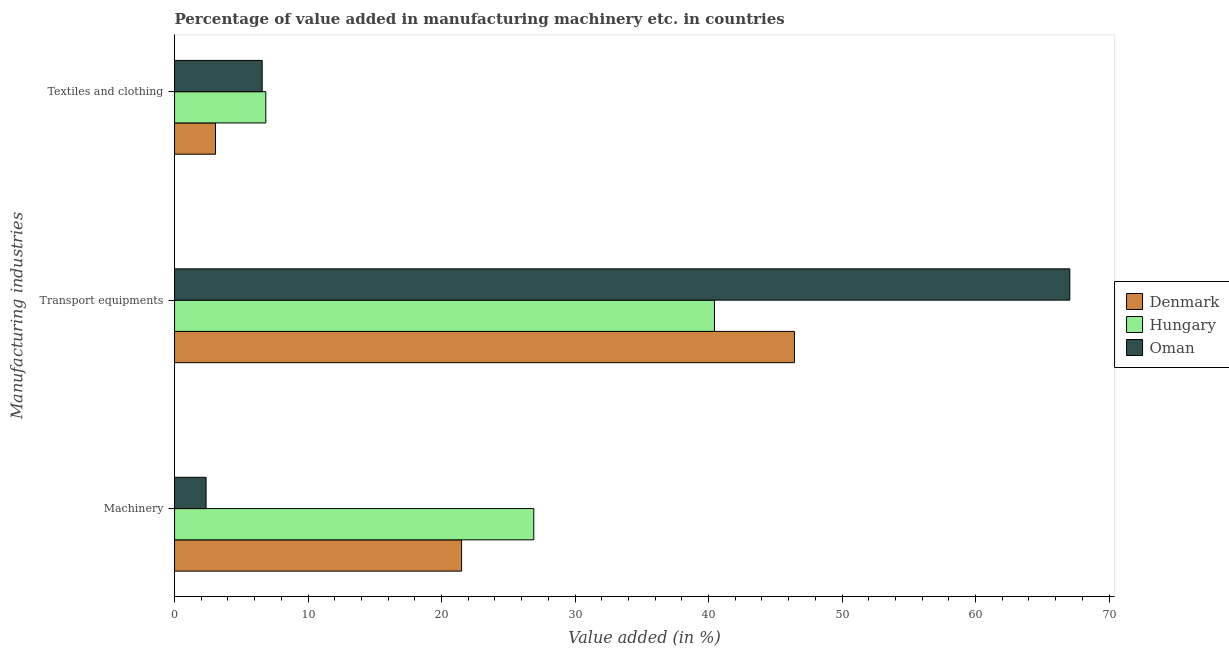How many different coloured bars are there?
Give a very brief answer. 3. How many bars are there on the 1st tick from the top?
Make the answer very short. 3. What is the label of the 3rd group of bars from the top?
Keep it short and to the point. Machinery. What is the value added in manufacturing textile and clothing in Oman?
Your answer should be compact. 6.56. Across all countries, what is the maximum value added in manufacturing textile and clothing?
Ensure brevity in your answer.  6.84. Across all countries, what is the minimum value added in manufacturing textile and clothing?
Your answer should be very brief. 3.07. In which country was the value added in manufacturing textile and clothing maximum?
Keep it short and to the point. Hungary. In which country was the value added in manufacturing machinery minimum?
Give a very brief answer. Oman. What is the total value added in manufacturing textile and clothing in the graph?
Keep it short and to the point. 16.47. What is the difference between the value added in manufacturing machinery in Oman and that in Hungary?
Offer a terse response. -24.55. What is the difference between the value added in manufacturing transport equipments in Oman and the value added in manufacturing machinery in Hungary?
Give a very brief answer. 40.15. What is the average value added in manufacturing textile and clothing per country?
Ensure brevity in your answer.  5.49. What is the difference between the value added in manufacturing textile and clothing and value added in manufacturing machinery in Hungary?
Give a very brief answer. -20.07. In how many countries, is the value added in manufacturing transport equipments greater than 38 %?
Make the answer very short. 3. What is the ratio of the value added in manufacturing textile and clothing in Oman to that in Hungary?
Offer a very short reply. 0.96. Is the difference between the value added in manufacturing transport equipments in Hungary and Denmark greater than the difference between the value added in manufacturing textile and clothing in Hungary and Denmark?
Provide a succinct answer. No. What is the difference between the highest and the second highest value added in manufacturing machinery?
Your answer should be very brief. 5.41. What is the difference between the highest and the lowest value added in manufacturing transport equipments?
Offer a very short reply. 26.62. What does the 1st bar from the top in Transport equipments represents?
Your answer should be very brief. Oman. What does the 2nd bar from the bottom in Machinery represents?
Offer a terse response. Hungary. Is it the case that in every country, the sum of the value added in manufacturing machinery and value added in manufacturing transport equipments is greater than the value added in manufacturing textile and clothing?
Your answer should be compact. Yes. How many bars are there?
Your answer should be compact. 9. Are all the bars in the graph horizontal?
Keep it short and to the point. Yes. How many countries are there in the graph?
Offer a very short reply. 3. What is the difference between two consecutive major ticks on the X-axis?
Your answer should be very brief. 10. Are the values on the major ticks of X-axis written in scientific E-notation?
Make the answer very short. No. Where does the legend appear in the graph?
Give a very brief answer. Center right. How many legend labels are there?
Offer a very short reply. 3. How are the legend labels stacked?
Make the answer very short. Vertical. What is the title of the graph?
Offer a terse response. Percentage of value added in manufacturing machinery etc. in countries. Does "Oman" appear as one of the legend labels in the graph?
Your answer should be very brief. Yes. What is the label or title of the X-axis?
Your response must be concise. Value added (in %). What is the label or title of the Y-axis?
Offer a terse response. Manufacturing industries. What is the Value added (in %) in Denmark in Machinery?
Your answer should be compact. 21.5. What is the Value added (in %) of Hungary in Machinery?
Your answer should be very brief. 26.91. What is the Value added (in %) in Oman in Machinery?
Give a very brief answer. 2.36. What is the Value added (in %) in Denmark in Transport equipments?
Your answer should be compact. 46.44. What is the Value added (in %) of Hungary in Transport equipments?
Offer a very short reply. 40.44. What is the Value added (in %) in Oman in Transport equipments?
Offer a terse response. 67.06. What is the Value added (in %) of Denmark in Textiles and clothing?
Ensure brevity in your answer.  3.07. What is the Value added (in %) of Hungary in Textiles and clothing?
Provide a short and direct response. 6.84. What is the Value added (in %) in Oman in Textiles and clothing?
Your response must be concise. 6.56. Across all Manufacturing industries, what is the maximum Value added (in %) of Denmark?
Provide a short and direct response. 46.44. Across all Manufacturing industries, what is the maximum Value added (in %) of Hungary?
Ensure brevity in your answer.  40.44. Across all Manufacturing industries, what is the maximum Value added (in %) of Oman?
Provide a succinct answer. 67.06. Across all Manufacturing industries, what is the minimum Value added (in %) in Denmark?
Your answer should be compact. 3.07. Across all Manufacturing industries, what is the minimum Value added (in %) in Hungary?
Ensure brevity in your answer.  6.84. Across all Manufacturing industries, what is the minimum Value added (in %) of Oman?
Ensure brevity in your answer.  2.36. What is the total Value added (in %) of Denmark in the graph?
Offer a very short reply. 71. What is the total Value added (in %) of Hungary in the graph?
Give a very brief answer. 74.19. What is the total Value added (in %) in Oman in the graph?
Keep it short and to the point. 75.99. What is the difference between the Value added (in %) of Denmark in Machinery and that in Transport equipments?
Your response must be concise. -24.93. What is the difference between the Value added (in %) of Hungary in Machinery and that in Transport equipments?
Your answer should be compact. -13.54. What is the difference between the Value added (in %) of Oman in Machinery and that in Transport equipments?
Keep it short and to the point. -64.7. What is the difference between the Value added (in %) of Denmark in Machinery and that in Textiles and clothing?
Give a very brief answer. 18.43. What is the difference between the Value added (in %) of Hungary in Machinery and that in Textiles and clothing?
Your answer should be compact. 20.07. What is the difference between the Value added (in %) of Oman in Machinery and that in Textiles and clothing?
Provide a succinct answer. -4.2. What is the difference between the Value added (in %) in Denmark in Transport equipments and that in Textiles and clothing?
Ensure brevity in your answer.  43.37. What is the difference between the Value added (in %) in Hungary in Transport equipments and that in Textiles and clothing?
Your answer should be very brief. 33.61. What is the difference between the Value added (in %) of Oman in Transport equipments and that in Textiles and clothing?
Your answer should be compact. 60.5. What is the difference between the Value added (in %) in Denmark in Machinery and the Value added (in %) in Hungary in Transport equipments?
Provide a succinct answer. -18.94. What is the difference between the Value added (in %) in Denmark in Machinery and the Value added (in %) in Oman in Transport equipments?
Give a very brief answer. -45.56. What is the difference between the Value added (in %) in Hungary in Machinery and the Value added (in %) in Oman in Transport equipments?
Provide a succinct answer. -40.15. What is the difference between the Value added (in %) in Denmark in Machinery and the Value added (in %) in Hungary in Textiles and clothing?
Keep it short and to the point. 14.67. What is the difference between the Value added (in %) of Denmark in Machinery and the Value added (in %) of Oman in Textiles and clothing?
Offer a very short reply. 14.94. What is the difference between the Value added (in %) of Hungary in Machinery and the Value added (in %) of Oman in Textiles and clothing?
Provide a short and direct response. 20.35. What is the difference between the Value added (in %) in Denmark in Transport equipments and the Value added (in %) in Hungary in Textiles and clothing?
Keep it short and to the point. 39.6. What is the difference between the Value added (in %) in Denmark in Transport equipments and the Value added (in %) in Oman in Textiles and clothing?
Keep it short and to the point. 39.87. What is the difference between the Value added (in %) in Hungary in Transport equipments and the Value added (in %) in Oman in Textiles and clothing?
Your response must be concise. 33.88. What is the average Value added (in %) in Denmark per Manufacturing industries?
Keep it short and to the point. 23.67. What is the average Value added (in %) of Hungary per Manufacturing industries?
Provide a succinct answer. 24.73. What is the average Value added (in %) of Oman per Manufacturing industries?
Make the answer very short. 25.33. What is the difference between the Value added (in %) in Denmark and Value added (in %) in Hungary in Machinery?
Offer a very short reply. -5.41. What is the difference between the Value added (in %) of Denmark and Value added (in %) of Oman in Machinery?
Offer a very short reply. 19.14. What is the difference between the Value added (in %) of Hungary and Value added (in %) of Oman in Machinery?
Keep it short and to the point. 24.55. What is the difference between the Value added (in %) in Denmark and Value added (in %) in Hungary in Transport equipments?
Offer a terse response. 5.99. What is the difference between the Value added (in %) of Denmark and Value added (in %) of Oman in Transport equipments?
Your response must be concise. -20.63. What is the difference between the Value added (in %) of Hungary and Value added (in %) of Oman in Transport equipments?
Offer a very short reply. -26.62. What is the difference between the Value added (in %) of Denmark and Value added (in %) of Hungary in Textiles and clothing?
Give a very brief answer. -3.77. What is the difference between the Value added (in %) in Denmark and Value added (in %) in Oman in Textiles and clothing?
Provide a succinct answer. -3.5. What is the difference between the Value added (in %) of Hungary and Value added (in %) of Oman in Textiles and clothing?
Ensure brevity in your answer.  0.27. What is the ratio of the Value added (in %) in Denmark in Machinery to that in Transport equipments?
Provide a succinct answer. 0.46. What is the ratio of the Value added (in %) of Hungary in Machinery to that in Transport equipments?
Make the answer very short. 0.67. What is the ratio of the Value added (in %) in Oman in Machinery to that in Transport equipments?
Make the answer very short. 0.04. What is the ratio of the Value added (in %) in Denmark in Machinery to that in Textiles and clothing?
Provide a succinct answer. 7.01. What is the ratio of the Value added (in %) of Hungary in Machinery to that in Textiles and clothing?
Provide a succinct answer. 3.94. What is the ratio of the Value added (in %) of Oman in Machinery to that in Textiles and clothing?
Your answer should be compact. 0.36. What is the ratio of the Value added (in %) in Denmark in Transport equipments to that in Textiles and clothing?
Make the answer very short. 15.14. What is the ratio of the Value added (in %) in Hungary in Transport equipments to that in Textiles and clothing?
Provide a succinct answer. 5.92. What is the ratio of the Value added (in %) of Oman in Transport equipments to that in Textiles and clothing?
Make the answer very short. 10.22. What is the difference between the highest and the second highest Value added (in %) of Denmark?
Your response must be concise. 24.93. What is the difference between the highest and the second highest Value added (in %) of Hungary?
Make the answer very short. 13.54. What is the difference between the highest and the second highest Value added (in %) of Oman?
Provide a short and direct response. 60.5. What is the difference between the highest and the lowest Value added (in %) of Denmark?
Give a very brief answer. 43.37. What is the difference between the highest and the lowest Value added (in %) of Hungary?
Offer a terse response. 33.61. What is the difference between the highest and the lowest Value added (in %) of Oman?
Offer a very short reply. 64.7. 